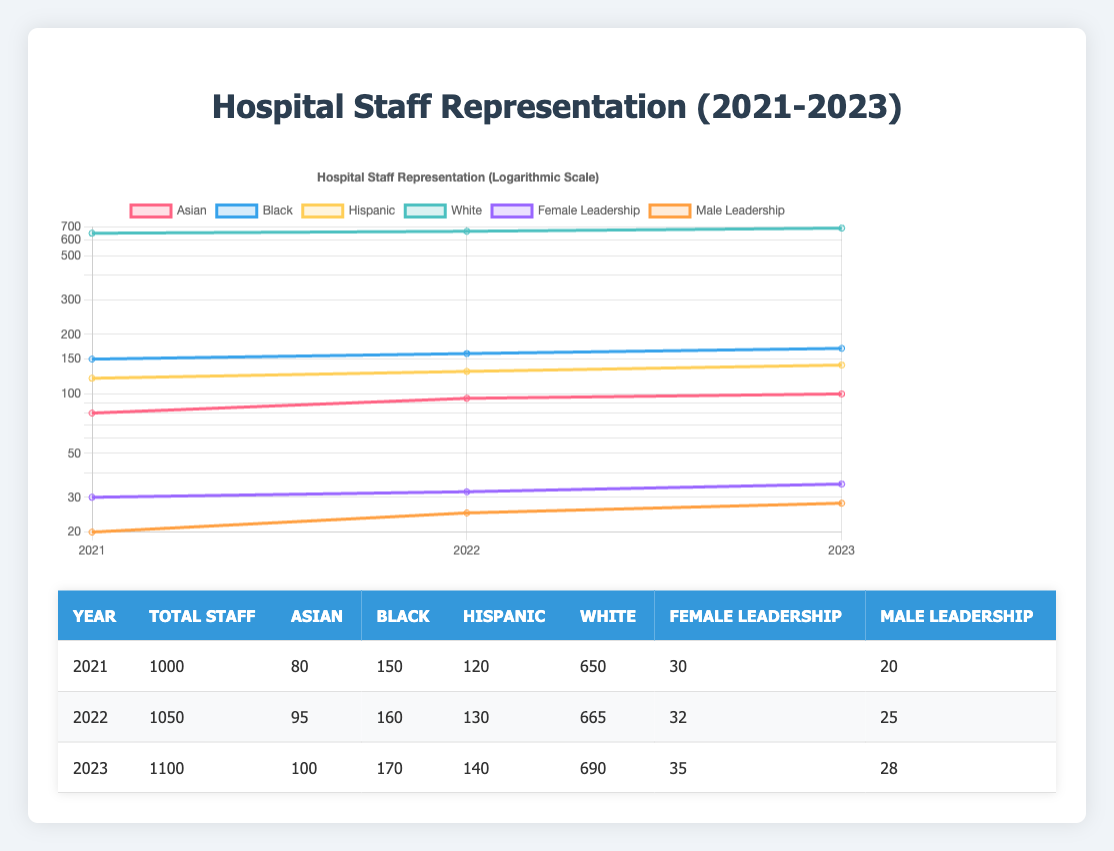What is the total number of hospital staff in 2023? In the table, for the year 2023, the column labeled "Total Staff" shows the value of 1100.
Answer: 1100 How many Black staff members were represented in 2022? Referring to the year 2022 in the table, the column "Black" shows that 160 Black staff members were represented.
Answer: 160 What is the percentage of Hispanic representation among total staff in 2021? For 2021, Hispanic representation is 120 out of 1000 total staff. The percentage is calculated as (120/1000) * 100 = 12%.
Answer: 12% Was there an increase in Female Leadership from 2021 to 2022? In 2021, the Female Leadership column shows 30, and in 2022, it shows 32. Comparing these figures, there was an increase of 2.
Answer: Yes What is the average number of male leadership positions from 2021 to 2023? Summing the values of Male Leadership for the years 2021 (20), 2022 (25), and 2023 (28), we get 20 + 25 + 28 = 73. The average is calculated by dividing by the total number of years: 73/3 = approximately 24.33.
Answer: 24.33 Which month experienced the greatest increase in representation of Black staff? The representation of Black staff increased from 150 in 2021 to 170 in 2023. The increase from 2021 to 2023 is 170 - 150 = 20, which spans across both years, but if we consider the growth per year, it's greater in 2023 than was seen cumulatively from the previous year.
Answer: 2023 What percentage did White representation decrease from 2021 to 2023? In 2021, White representation was 650, and in 2023 it is 690, indicating an increase, thus it did not decrease. The percentage change does not apply.
Answer: No decrease How many total leadership positions are there in 2022? For 2022, the sum of Female Leadership (32) and Male Leadership (25) gives a total of 32 + 25 = 57 leadership positions.
Answer: 57 What is the difference in Hispanic representation between 2021 and 2023? In 2021, representation for Hispanic staff is 120, while in 2023 it is 140. The difference is calculated as 140 - 120 = 20.
Answer: 20 What was the total representation of Asian staff over the three years combined? Adding the Asian representation for 2021 (80), 2022 (95), and 2023 (100) gives a total of 80 + 95 + 100 = 275.
Answer: 275 